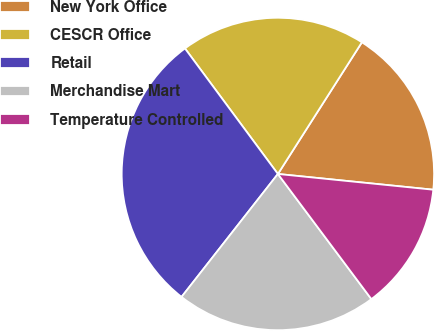Convert chart. <chart><loc_0><loc_0><loc_500><loc_500><pie_chart><fcel>New York Office<fcel>CESCR Office<fcel>Retail<fcel>Merchandise Mart<fcel>Temperature Controlled<nl><fcel>17.57%<fcel>19.18%<fcel>29.28%<fcel>20.79%<fcel>13.18%<nl></chart> 